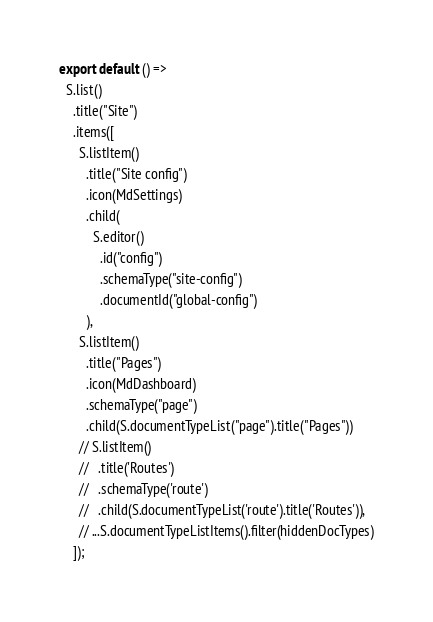<code> <loc_0><loc_0><loc_500><loc_500><_JavaScript_>
export default () =>
  S.list()
    .title("Site")
    .items([
      S.listItem()
        .title("Site config")
        .icon(MdSettings)
        .child(
          S.editor()
            .id("config")
            .schemaType("site-config")
            .documentId("global-config")
        ),
      S.listItem()
        .title("Pages")
        .icon(MdDashboard)
        .schemaType("page")
        .child(S.documentTypeList("page").title("Pages"))
      // S.listItem()
      //   .title('Routes')
      //   .schemaType('route')
      //   .child(S.documentTypeList('route').title('Routes')),
      // ...S.documentTypeListItems().filter(hiddenDocTypes)
    ]);
</code> 